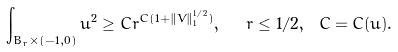Convert formula to latex. <formula><loc_0><loc_0><loc_500><loc_500>\int _ { B _ { r } \times ( - 1 , 0 ) } u ^ { 2 } \geq C r ^ { C ( 1 + \| V \| _ { 1 } ^ { 1 / 2 } ) } , \ \ r \leq 1 / 2 , \ C = C ( u ) .</formula> 